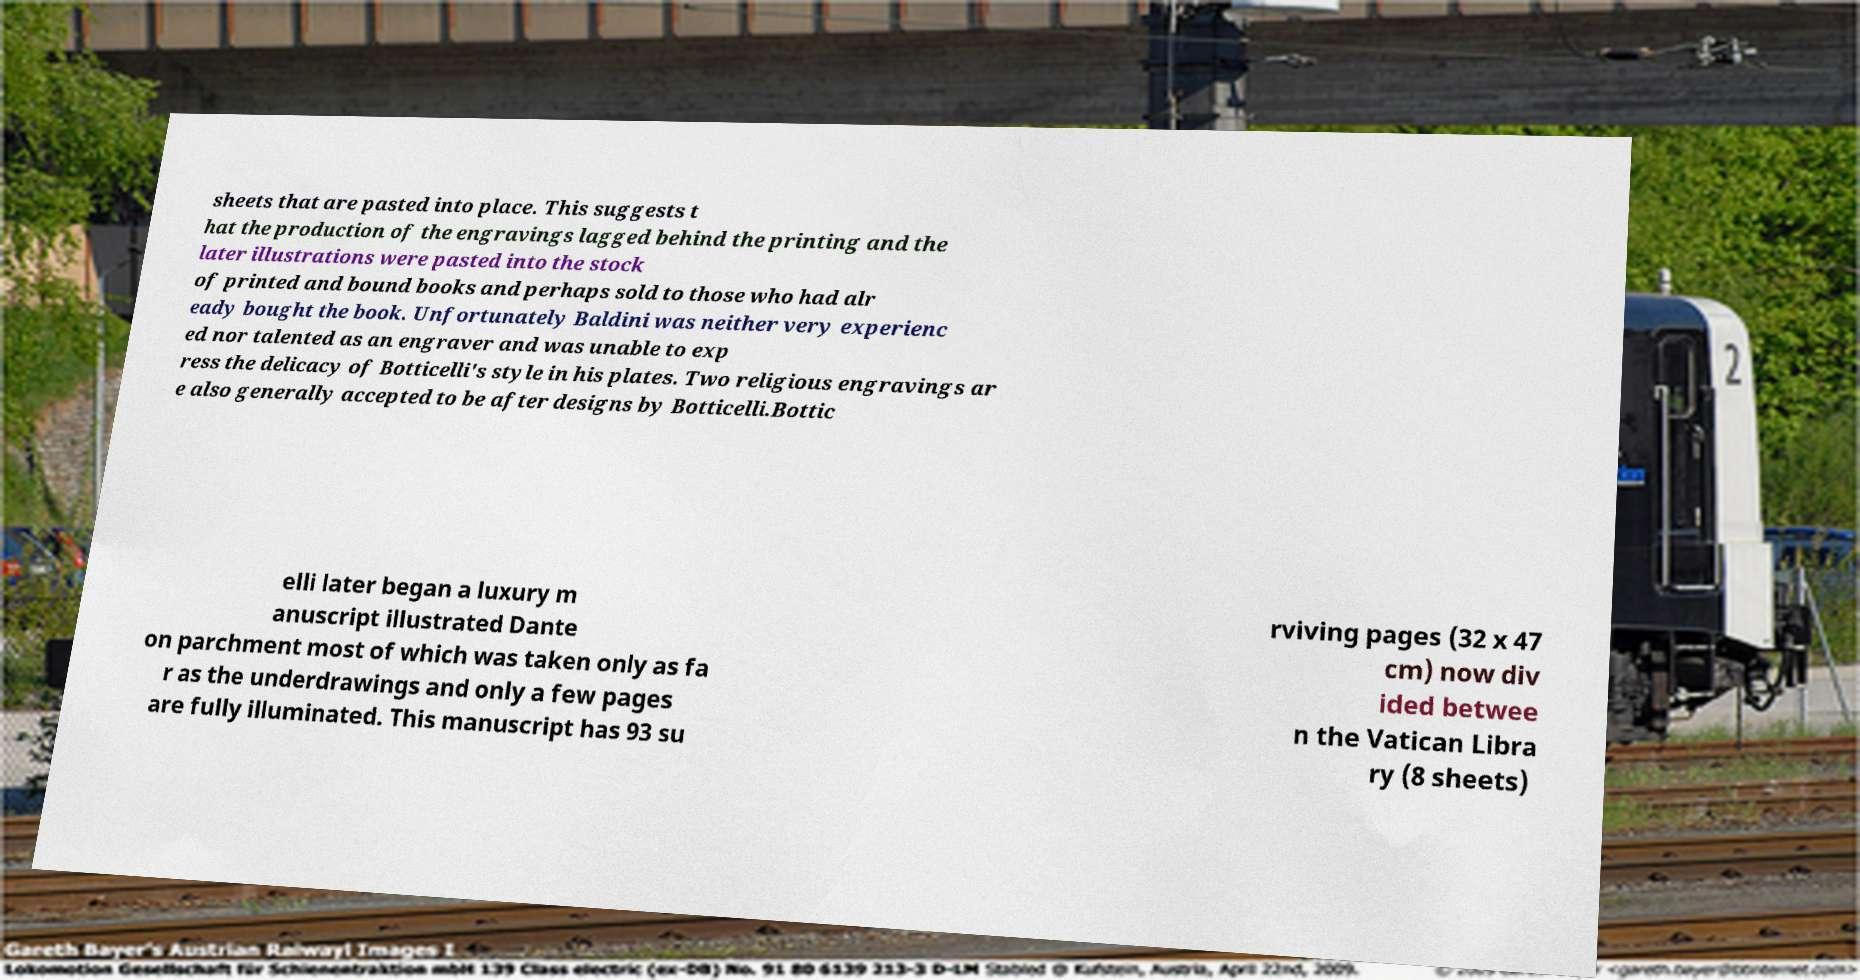Please read and relay the text visible in this image. What does it say? sheets that are pasted into place. This suggests t hat the production of the engravings lagged behind the printing and the later illustrations were pasted into the stock of printed and bound books and perhaps sold to those who had alr eady bought the book. Unfortunately Baldini was neither very experienc ed nor talented as an engraver and was unable to exp ress the delicacy of Botticelli's style in his plates. Two religious engravings ar e also generally accepted to be after designs by Botticelli.Bottic elli later began a luxury m anuscript illustrated Dante on parchment most of which was taken only as fa r as the underdrawings and only a few pages are fully illuminated. This manuscript has 93 su rviving pages (32 x 47 cm) now div ided betwee n the Vatican Libra ry (8 sheets) 